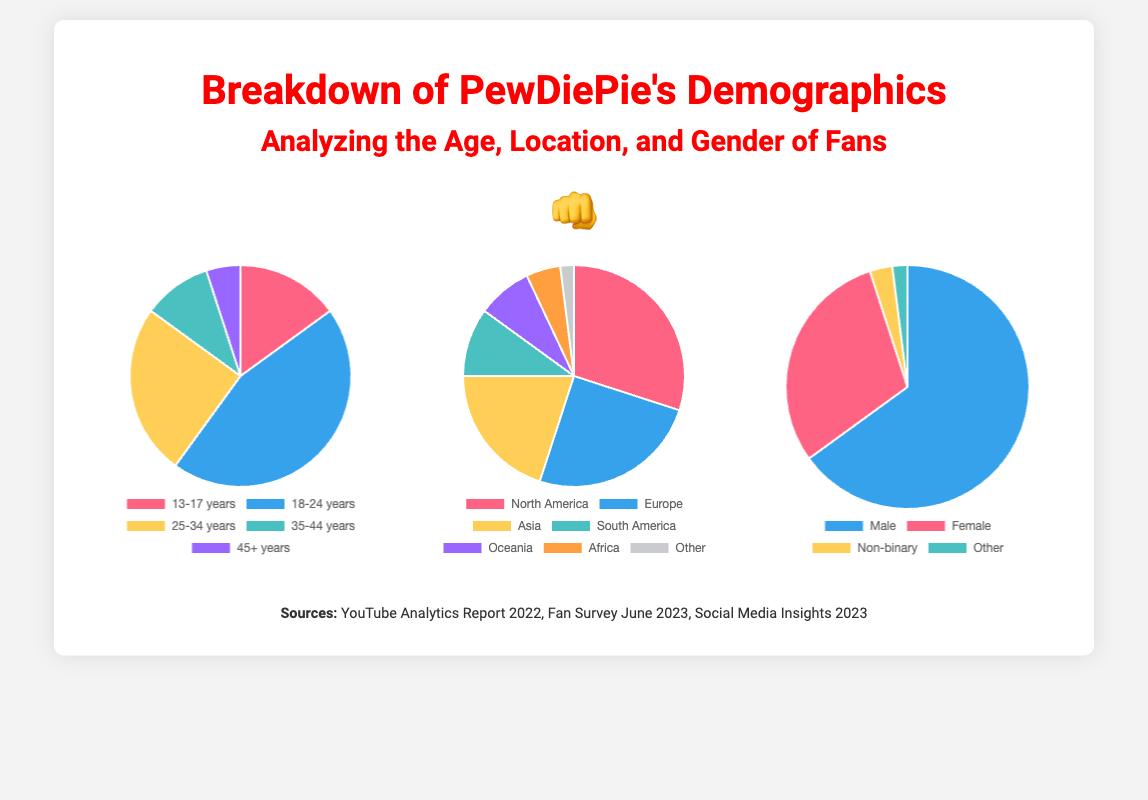what is the largest age group among PewDiePie's fans? The largest age group among PewDiePie's fans is 18-24 years, which constitutes 45% of the audience.
Answer: 18-24 years what percentage of PewDiePie's fans are male? The percentage of male fans is indicated in the document as 65%.
Answer: 65% which continent has the highest percentage of PewDiePie's fan base? The continent with the highest percentage is North America, accounting for 30% of the fan base.
Answer: North America what is the combined percentage of fans aged 25 years and older? The combined percentage of fans aged 25 years and older is found by adding the percentages of the age groups 25-34 years, 35-44 years, and 45+ years, which are 25%, 10%, and 5%, respectively.
Answer: 40% what is the total percentage of PewDiePie's fans from Europe and Asia? The total percentage from Europe and Asia is calculated by summing their respective percentages of 25% and 20%.
Answer: 45% what portion of PewDiePie's fans identify as non-binary? The document specifies that 3% of fans identify as non-binary.
Answer: 3% what is the total number of geographic regions represented in the fan distribution chart? The total number of geographic regions in the fan distribution chart is seven, as listed in the document.
Answer: seven which gender category has the smallest representation among PewDiePie's fans? The smallest representation among fans is found in the 'Other' gender category, which has 2%.
Answer: Other 